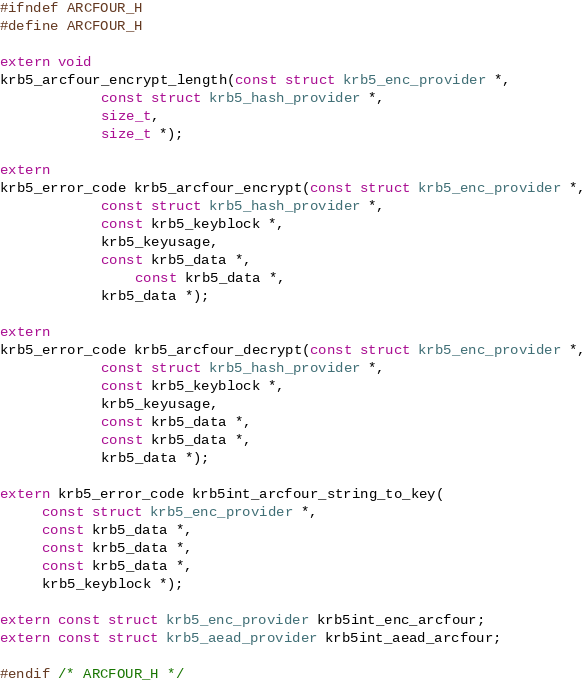<code> <loc_0><loc_0><loc_500><loc_500><_C_>#ifndef ARCFOUR_H
#define ARCFOUR_H

extern void
krb5_arcfour_encrypt_length(const struct krb5_enc_provider *,
			const struct krb5_hash_provider *,
			size_t,
			size_t *);

extern 
krb5_error_code krb5_arcfour_encrypt(const struct krb5_enc_provider *,
			const struct krb5_hash_provider *,
			const krb5_keyblock *,
			krb5_keyusage,
			const krb5_data *,
     			const krb5_data *,
			krb5_data *);

extern 
krb5_error_code krb5_arcfour_decrypt(const struct krb5_enc_provider *,
			const struct krb5_hash_provider *,
			const krb5_keyblock *,
			krb5_keyusage,
			const krb5_data *,
			const krb5_data *,
			krb5_data *);

extern krb5_error_code krb5int_arcfour_string_to_key(
     const struct krb5_enc_provider *,
     const krb5_data *,
     const krb5_data *,
     const krb5_data *,
     krb5_keyblock *);

extern const struct krb5_enc_provider krb5int_enc_arcfour;
extern const struct krb5_aead_provider krb5int_aead_arcfour;

#endif /* ARCFOUR_H */
</code> 